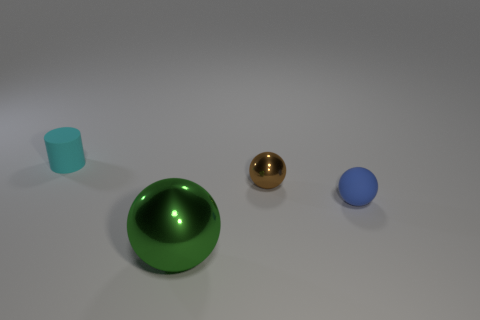What is the color of the small matte object to the left of the sphere left of the shiny ball behind the big green sphere?
Your answer should be very brief. Cyan. What is the shape of the brown thing that is the same material as the green sphere?
Offer a very short reply. Sphere. Is the number of large cyan rubber spheres less than the number of small cylinders?
Provide a short and direct response. Yes. Is the brown ball made of the same material as the big object?
Offer a terse response. Yes. What number of other objects are the same color as the large sphere?
Your response must be concise. 0. Is the number of tiny cyan matte objects greater than the number of small rubber things?
Your answer should be very brief. No. There is a cylinder; does it have the same size as the shiny ball behind the large green metallic object?
Provide a succinct answer. Yes. What is the color of the tiny rubber thing on the left side of the big green sphere?
Make the answer very short. Cyan. How many blue things are either tiny things or big shiny balls?
Provide a succinct answer. 1. What color is the matte cylinder?
Your answer should be very brief. Cyan. 